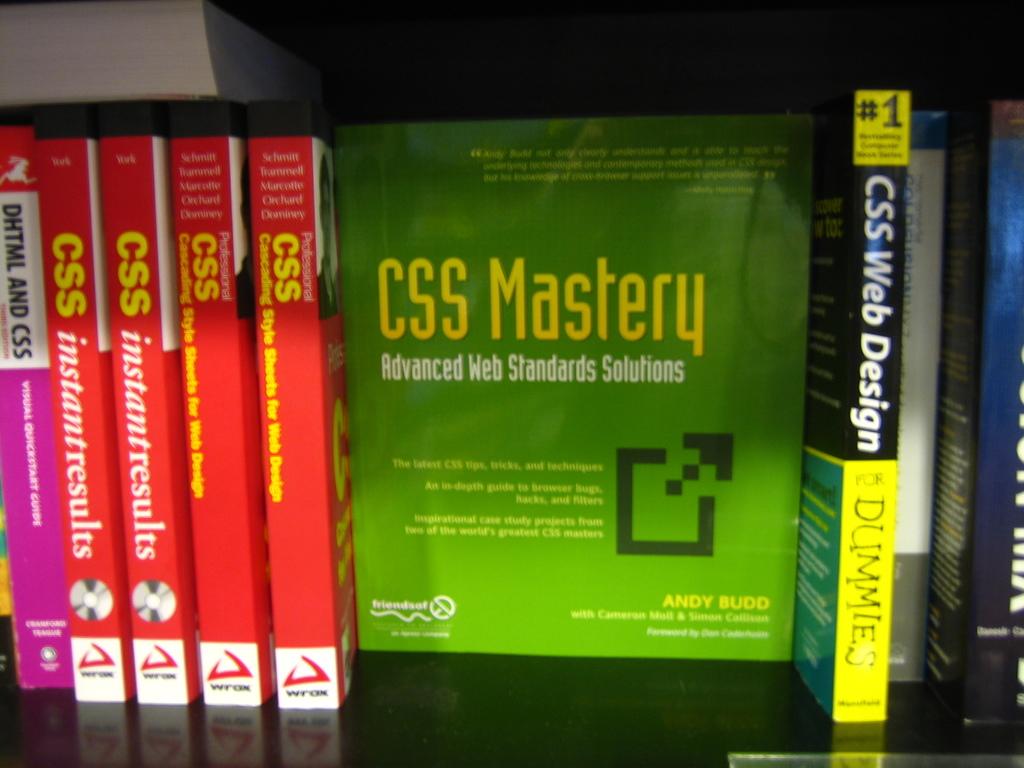Who is the book on the right for?
Provide a succinct answer. Dummies. 